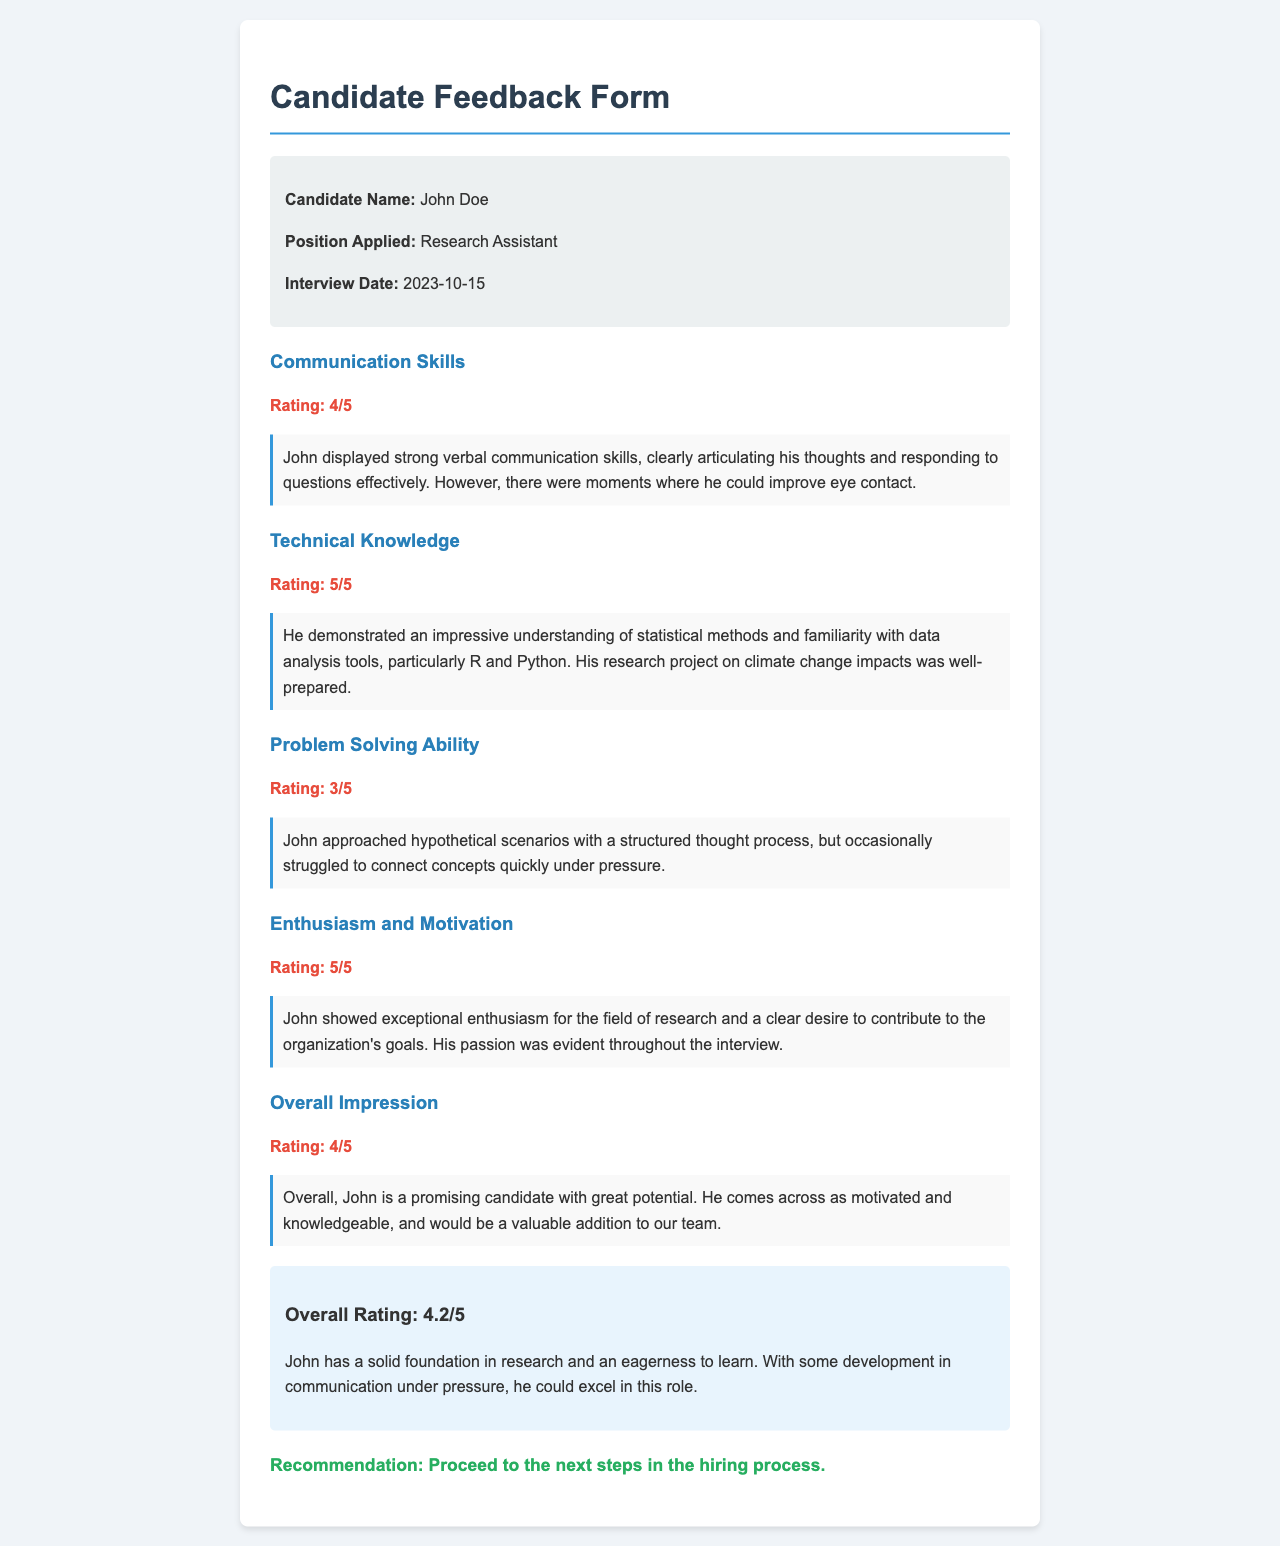What is the candidate's name? The candidate's name is provided in the candidate info section, which is John Doe.
Answer: John Doe What position did John Doe apply for? The position applied for is stated in the candidate info section, which is Research Assistant.
Answer: Research Assistant What date was the interview conducted? The interview date is explicitly mentioned in the candidate info section as 2023-10-15.
Answer: 2023-10-15 What rating did John receive for technical knowledge? The rating for technical knowledge is given in the corresponding section, which is 5 out of 5.
Answer: 5/5 What was the overall impression rating for John? The overall impression rating is stated in the document as 4 out of 5.
Answer: 4/5 How did John score in problem-solving ability? The score for problem-solving ability is included in that section and is 3 out of 5.
Answer: 3/5 What aspect of John's communication skills needed improvement? The comments in the communication skills section indicate that he needed improvement in eye contact.
Answer: Eye contact What was John’s enthusiasm and motivation rating? The enthusiasm and motivation rating is specified as 5 out of 5 in the respective section.
Answer: 5/5 What recommendation was made regarding John? The recommendation is clearly stated at the end of the document as proceeding to the next steps in the hiring process.
Answer: Proceed to the next steps 